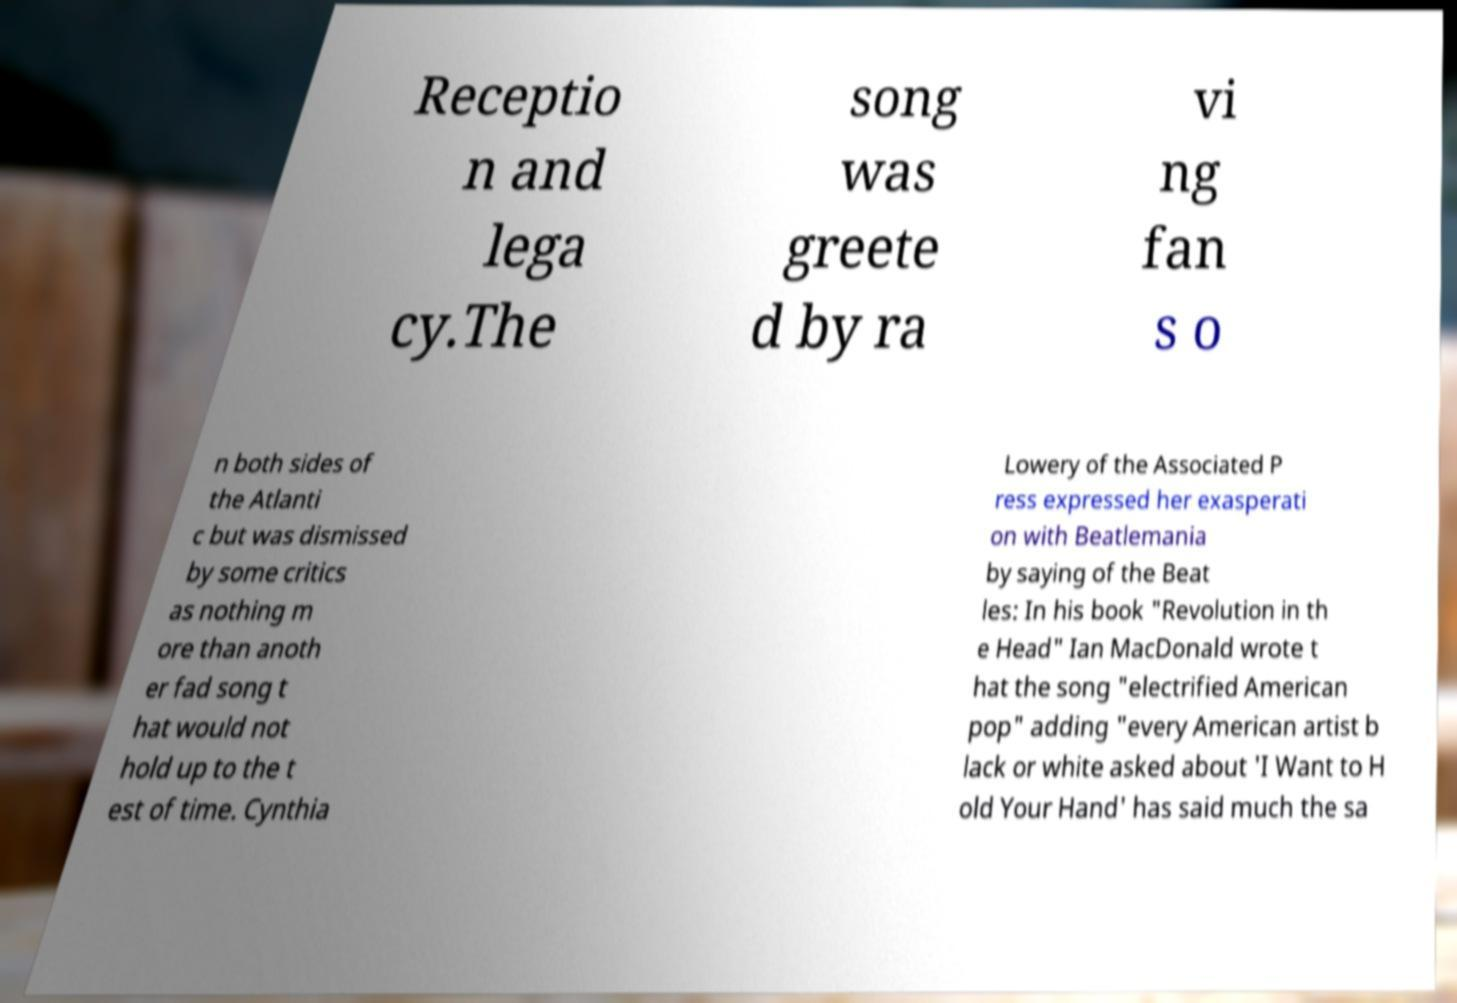For documentation purposes, I need the text within this image transcribed. Could you provide that? Receptio n and lega cy.The song was greete d by ra vi ng fan s o n both sides of the Atlanti c but was dismissed by some critics as nothing m ore than anoth er fad song t hat would not hold up to the t est of time. Cynthia Lowery of the Associated P ress expressed her exasperati on with Beatlemania by saying of the Beat les: In his book "Revolution in th e Head" Ian MacDonald wrote t hat the song "electrified American pop" adding "every American artist b lack or white asked about 'I Want to H old Your Hand' has said much the sa 